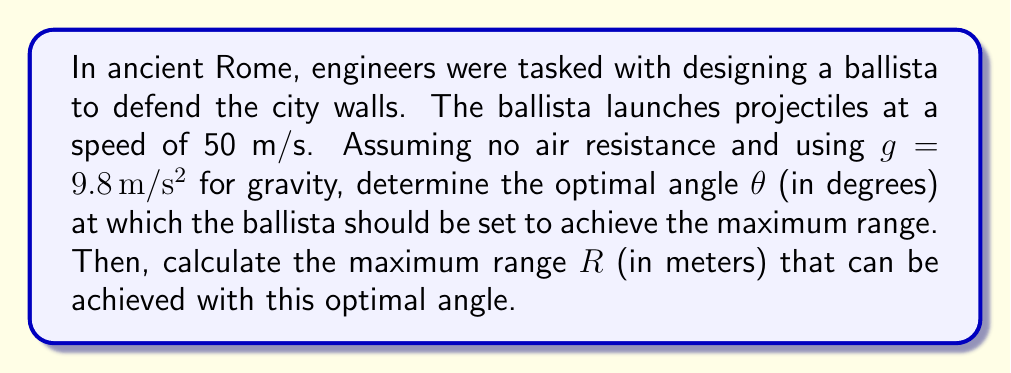Provide a solution to this math problem. To solve this problem, we'll use concepts from trigonometry and calculus:

1) The range R of a projectile launched at an angle θ with initial velocity v is given by:

   $$R = \frac{v^2 \sin(2θ)}{g}$$

2) To find the optimal angle for maximum range, we need to maximize this function. We can do this by finding where its derivative with respect to θ equals zero:

   $$\frac{dR}{dθ} = \frac{v^2}{g} \cdot 2\cos(2θ) = 0$$

3) Solving this equation:
   
   $$2\cos(2θ) = 0$$
   $$\cos(2θ) = 0$$
   $$2θ = 90°$$
   $$θ = 45°$$

4) The second derivative is negative at θ = 45°, confirming this is a maximum.

5) Now that we know the optimal angle, we can calculate the maximum range:

   $$R = \frac{v^2 \sin(2 \cdot 45°)}{g}$$
   $$R = \frac{50^2 \sin(90°)}{9.8}$$
   $$R = \frac{2500 \cdot 1}{9.8}$$
   $$R = 255.1 \text{ meters}$$

This result shows that Roman engineers could theoretically achieve a range of about 255 meters with their ballista, which would have been a formidable defense for city walls.
Answer: The optimal angle θ = 45°
The maximum range R ≈ 255.1 meters 